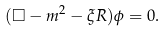Convert formula to latex. <formula><loc_0><loc_0><loc_500><loc_500>( \Box - m ^ { 2 } - \xi R ) \phi = 0 .</formula> 